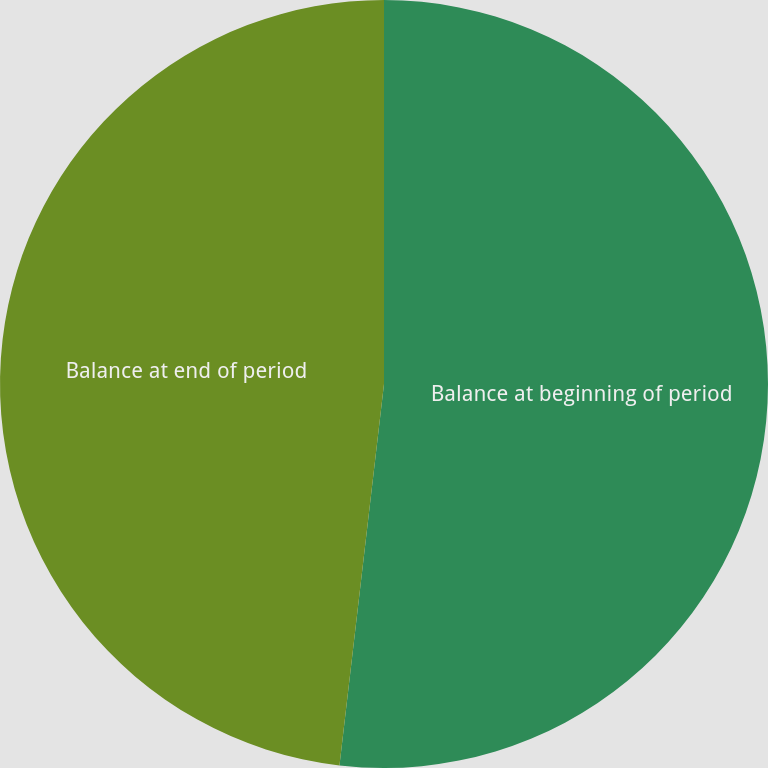Convert chart to OTSL. <chart><loc_0><loc_0><loc_500><loc_500><pie_chart><fcel>Balance at beginning of period<fcel>Balance at end of period<nl><fcel>51.85%<fcel>48.15%<nl></chart> 